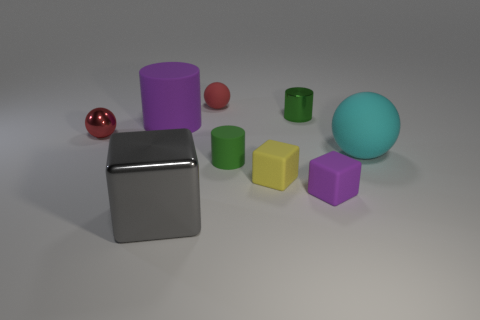What size is the purple cube that is made of the same material as the cyan ball?
Offer a very short reply. Small. Is there any other thing that is the same color as the metallic sphere?
Offer a very short reply. Yes. Do the yellow thing and the cylinder that is to the right of the green rubber cylinder have the same material?
Provide a succinct answer. No. What material is the gray object that is the same shape as the yellow rubber object?
Your answer should be very brief. Metal. Are there any other things that have the same material as the large purple thing?
Your response must be concise. Yes. Are the big cyan ball in front of the tiny red matte ball and the object that is behind the tiny green metal object made of the same material?
Make the answer very short. Yes. The small ball that is behind the green cylinder that is to the right of the rubber cube that is on the left side of the tiny green metallic cylinder is what color?
Keep it short and to the point. Red. What number of other objects are there of the same shape as the tiny purple thing?
Offer a terse response. 2. Does the big cylinder have the same color as the tiny shiny sphere?
Give a very brief answer. No. What number of objects are cyan spheres or metallic objects that are in front of the small red metal thing?
Your response must be concise. 2. 